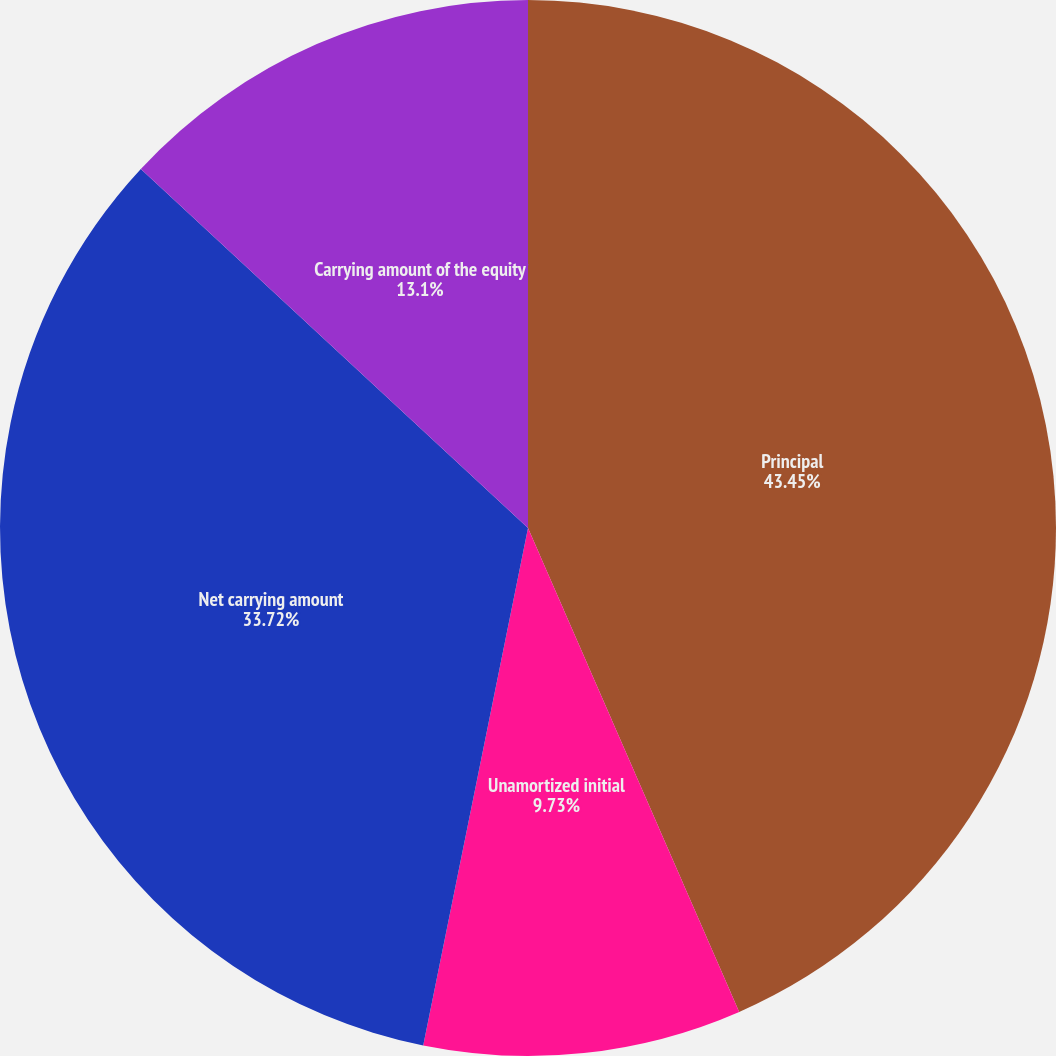Convert chart to OTSL. <chart><loc_0><loc_0><loc_500><loc_500><pie_chart><fcel>Principal<fcel>Unamortized initial<fcel>Net carrying amount<fcel>Carrying amount of the equity<nl><fcel>43.45%<fcel>9.73%<fcel>33.72%<fcel>13.1%<nl></chart> 